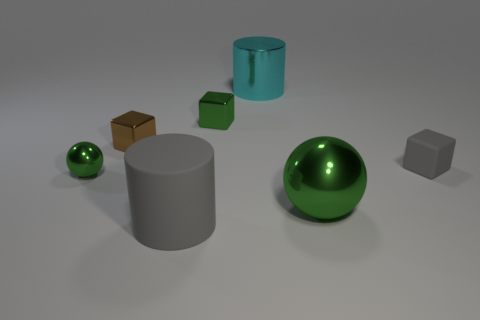Subtract all brown spheres. Subtract all red cylinders. How many spheres are left? 2 Add 1 large cyan cylinders. How many objects exist? 8 Subtract all blocks. How many objects are left? 4 Add 6 red metal cubes. How many red metal cubes exist? 6 Subtract 1 gray cylinders. How many objects are left? 6 Subtract all large blue balls. Subtract all brown cubes. How many objects are left? 6 Add 1 tiny spheres. How many tiny spheres are left? 2 